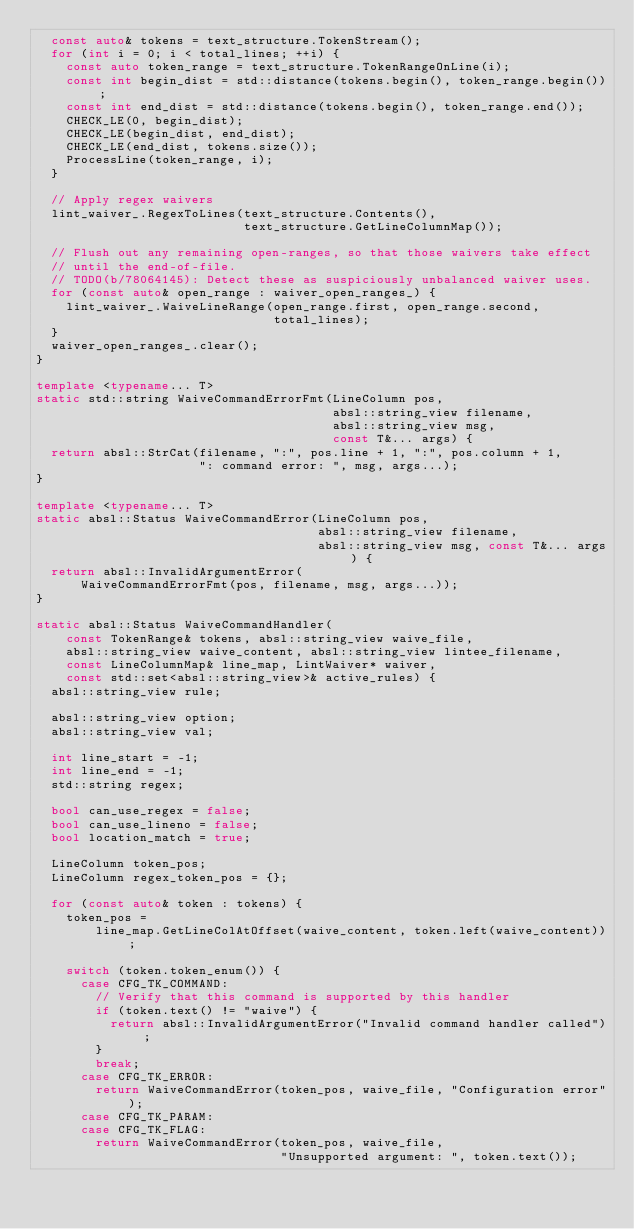<code> <loc_0><loc_0><loc_500><loc_500><_C++_>  const auto& tokens = text_structure.TokenStream();
  for (int i = 0; i < total_lines; ++i) {
    const auto token_range = text_structure.TokenRangeOnLine(i);
    const int begin_dist = std::distance(tokens.begin(), token_range.begin());
    const int end_dist = std::distance(tokens.begin(), token_range.end());
    CHECK_LE(0, begin_dist);
    CHECK_LE(begin_dist, end_dist);
    CHECK_LE(end_dist, tokens.size());
    ProcessLine(token_range, i);
  }

  // Apply regex waivers
  lint_waiver_.RegexToLines(text_structure.Contents(),
                            text_structure.GetLineColumnMap());

  // Flush out any remaining open-ranges, so that those waivers take effect
  // until the end-of-file.
  // TODO(b/78064145): Detect these as suspiciously unbalanced waiver uses.
  for (const auto& open_range : waiver_open_ranges_) {
    lint_waiver_.WaiveLineRange(open_range.first, open_range.second,
                                total_lines);
  }
  waiver_open_ranges_.clear();
}

template <typename... T>
static std::string WaiveCommandErrorFmt(LineColumn pos,
                                        absl::string_view filename,
                                        absl::string_view msg,
                                        const T&... args) {
  return absl::StrCat(filename, ":", pos.line + 1, ":", pos.column + 1,
                      ": command error: ", msg, args...);
}

template <typename... T>
static absl::Status WaiveCommandError(LineColumn pos,
                                      absl::string_view filename,
                                      absl::string_view msg, const T&... args) {
  return absl::InvalidArgumentError(
      WaiveCommandErrorFmt(pos, filename, msg, args...));
}

static absl::Status WaiveCommandHandler(
    const TokenRange& tokens, absl::string_view waive_file,
    absl::string_view waive_content, absl::string_view lintee_filename,
    const LineColumnMap& line_map, LintWaiver* waiver,
    const std::set<absl::string_view>& active_rules) {
  absl::string_view rule;

  absl::string_view option;
  absl::string_view val;

  int line_start = -1;
  int line_end = -1;
  std::string regex;

  bool can_use_regex = false;
  bool can_use_lineno = false;
  bool location_match = true;

  LineColumn token_pos;
  LineColumn regex_token_pos = {};

  for (const auto& token : tokens) {
    token_pos =
        line_map.GetLineColAtOffset(waive_content, token.left(waive_content));

    switch (token.token_enum()) {
      case CFG_TK_COMMAND:
        // Verify that this command is supported by this handler
        if (token.text() != "waive") {
          return absl::InvalidArgumentError("Invalid command handler called");
        }
        break;
      case CFG_TK_ERROR:
        return WaiveCommandError(token_pos, waive_file, "Configuration error");
      case CFG_TK_PARAM:
      case CFG_TK_FLAG:
        return WaiveCommandError(token_pos, waive_file,
                                 "Unsupported argument: ", token.text());</code> 